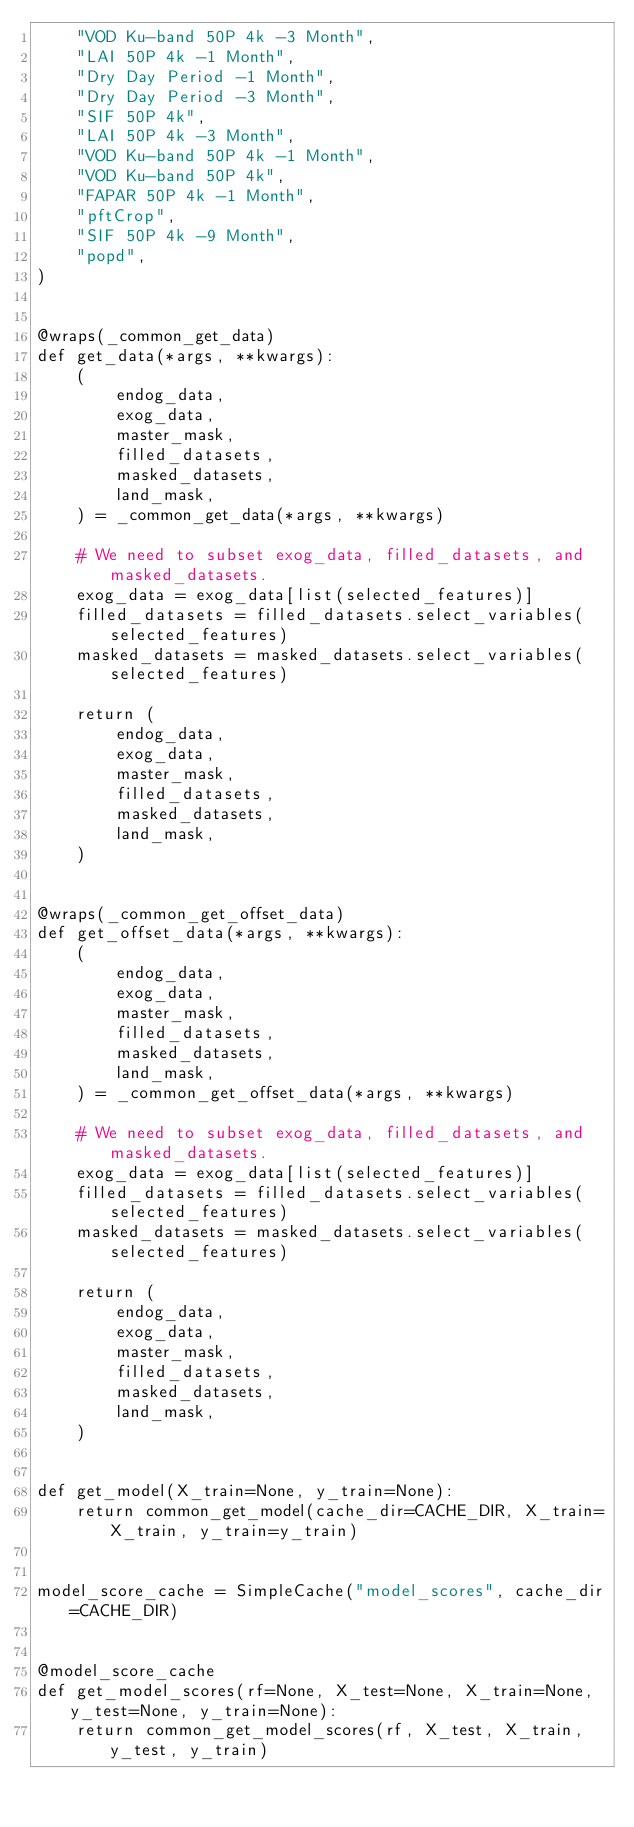Convert code to text. <code><loc_0><loc_0><loc_500><loc_500><_Python_>    "VOD Ku-band 50P 4k -3 Month",
    "LAI 50P 4k -1 Month",
    "Dry Day Period -1 Month",
    "Dry Day Period -3 Month",
    "SIF 50P 4k",
    "LAI 50P 4k -3 Month",
    "VOD Ku-band 50P 4k -1 Month",
    "VOD Ku-band 50P 4k",
    "FAPAR 50P 4k -1 Month",
    "pftCrop",
    "SIF 50P 4k -9 Month",
    "popd",
)


@wraps(_common_get_data)
def get_data(*args, **kwargs):
    (
        endog_data,
        exog_data,
        master_mask,
        filled_datasets,
        masked_datasets,
        land_mask,
    ) = _common_get_data(*args, **kwargs)

    # We need to subset exog_data, filled_datasets, and masked_datasets.
    exog_data = exog_data[list(selected_features)]
    filled_datasets = filled_datasets.select_variables(selected_features)
    masked_datasets = masked_datasets.select_variables(selected_features)

    return (
        endog_data,
        exog_data,
        master_mask,
        filled_datasets,
        masked_datasets,
        land_mask,
    )


@wraps(_common_get_offset_data)
def get_offset_data(*args, **kwargs):
    (
        endog_data,
        exog_data,
        master_mask,
        filled_datasets,
        masked_datasets,
        land_mask,
    ) = _common_get_offset_data(*args, **kwargs)

    # We need to subset exog_data, filled_datasets, and masked_datasets.
    exog_data = exog_data[list(selected_features)]
    filled_datasets = filled_datasets.select_variables(selected_features)
    masked_datasets = masked_datasets.select_variables(selected_features)

    return (
        endog_data,
        exog_data,
        master_mask,
        filled_datasets,
        masked_datasets,
        land_mask,
    )


def get_model(X_train=None, y_train=None):
    return common_get_model(cache_dir=CACHE_DIR, X_train=X_train, y_train=y_train)


model_score_cache = SimpleCache("model_scores", cache_dir=CACHE_DIR)


@model_score_cache
def get_model_scores(rf=None, X_test=None, X_train=None, y_test=None, y_train=None):
    return common_get_model_scores(rf, X_test, X_train, y_test, y_train)
</code> 